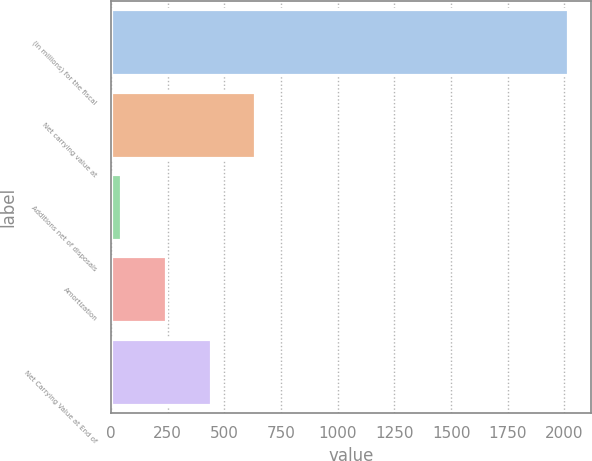Convert chart to OTSL. <chart><loc_0><loc_0><loc_500><loc_500><bar_chart><fcel>(in millions) for the fiscal<fcel>Net carrying value at<fcel>Additions net of disposals<fcel>Amortization<fcel>Net Carrying Value at End of<nl><fcel>2016<fcel>637.14<fcel>46.2<fcel>243.18<fcel>440.16<nl></chart> 